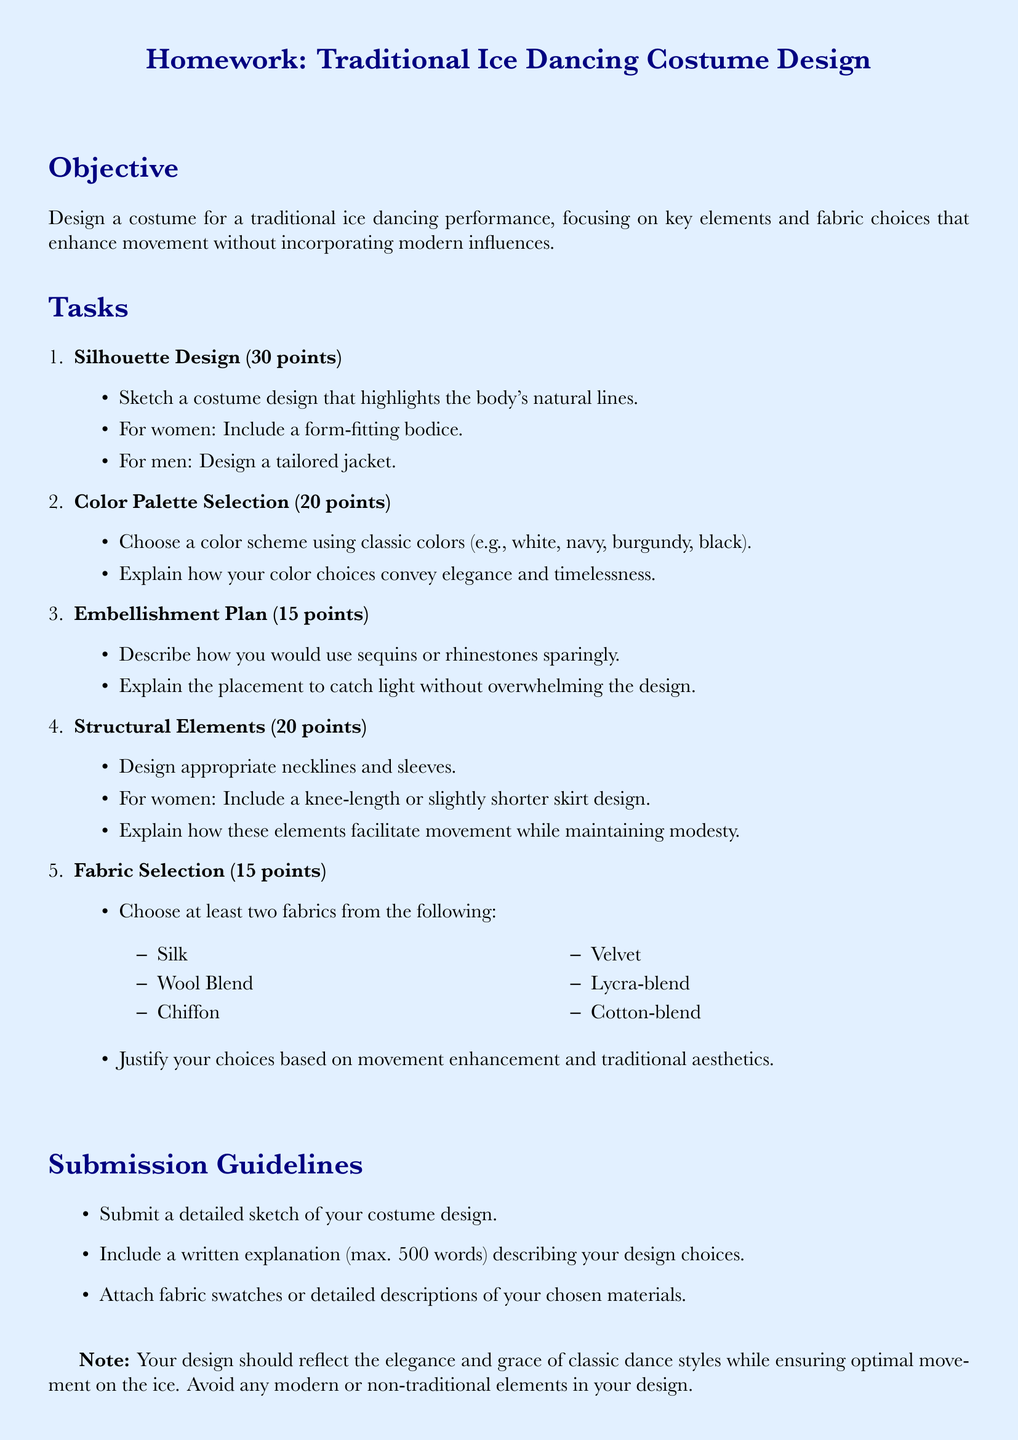What is the total point value for the silhouette design task? The total point value for the silhouette design task is mentioned in the document, which is 30 points.
Answer: 30 points What color choices are emphasized for the palette? The document specifies classic colors that should be chosen for the palette.
Answer: white, navy, burgundy, black How many fabrics must be selected for the costume design? The document states that at least two fabrics must be chosen from the list.
Answer: at least two What necklines and sleeve designs are required for women? The document describes the requirement for women's design, specifically mentioning necklines and sleeves.
Answer: appropriate necklines and sleeves What is the maximum word limit for the written explanation? The document specifies constraints for the written explanation's length.
Answer: 500 words What is one suggested fabric that can be included in the costume design? The document lists specific fabrics, one of which can be utilized for the costume.
Answer: Silk How should embellishments be applied according to the document? The document explains the approach to embellishments in the costume design task.
Answer: Sparingly What element of the costume design is crucial for enhancing movement? The document emphasizes important aspects related to the enhancement of movement in costume design.
Answer: Fabric choices 